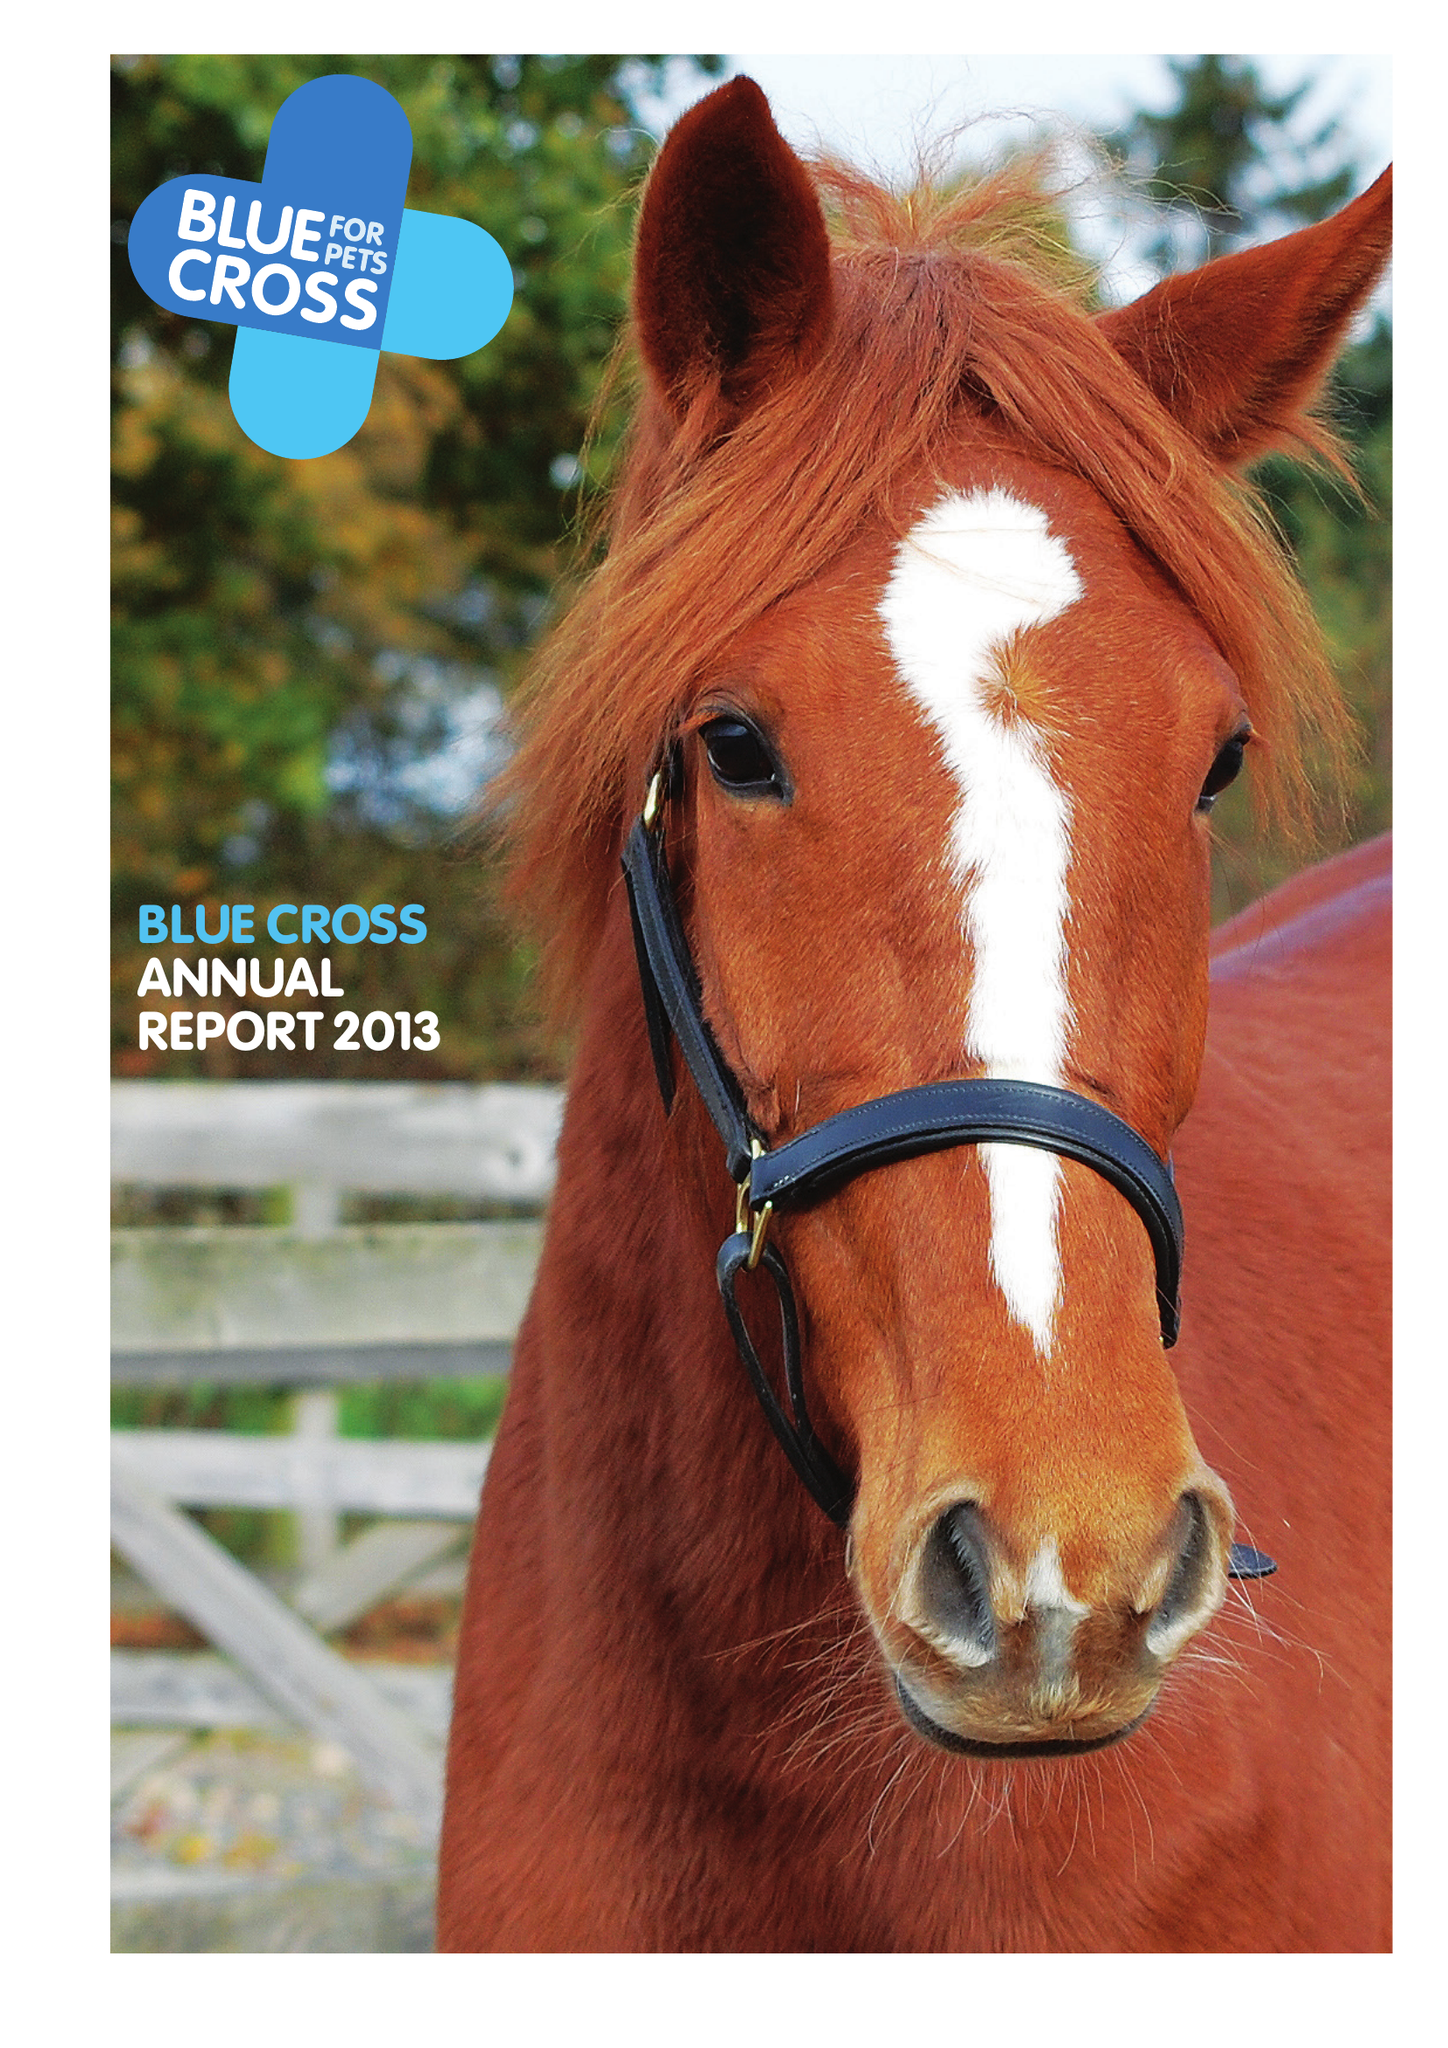What is the value for the report_date?
Answer the question using a single word or phrase. 2013-12-31 